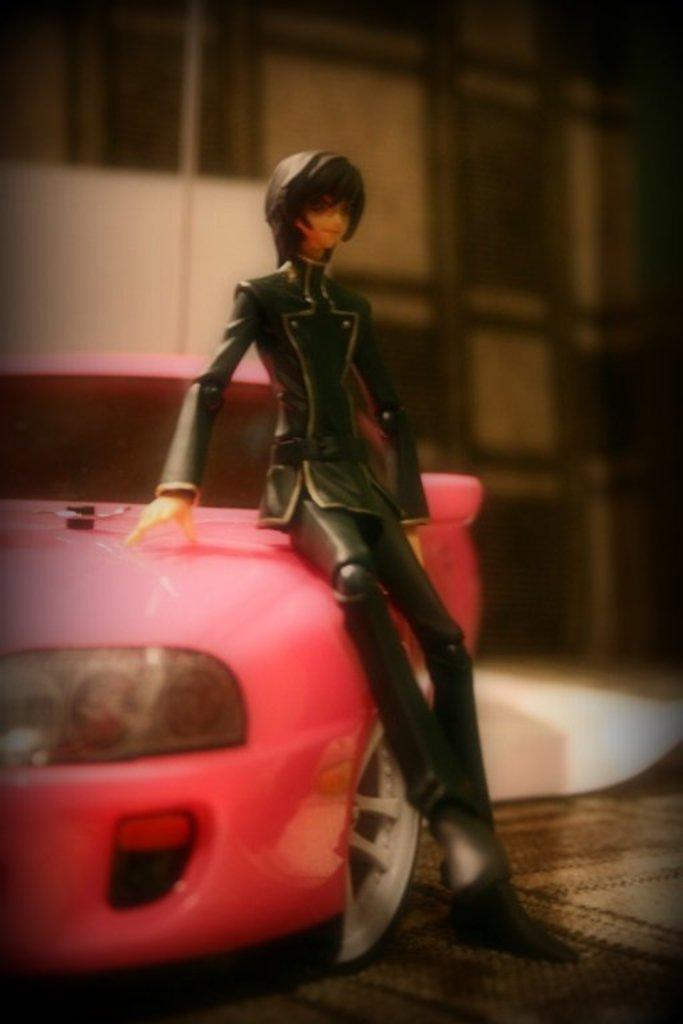What type of toy can be seen in the image? There is a pink toy car in the image. What other object is present in the image? There is a doll in the image. What is the doll wearing? The doll is wearing a black dress. Can you describe the quality of the image? The image is slightly blurry in the background. Is there a throne present in the image? No, there is no throne present in the image. What beliefs are represented by the objects in the image? The image does not provide any information about beliefs, as it only describes the objects present in the image. 